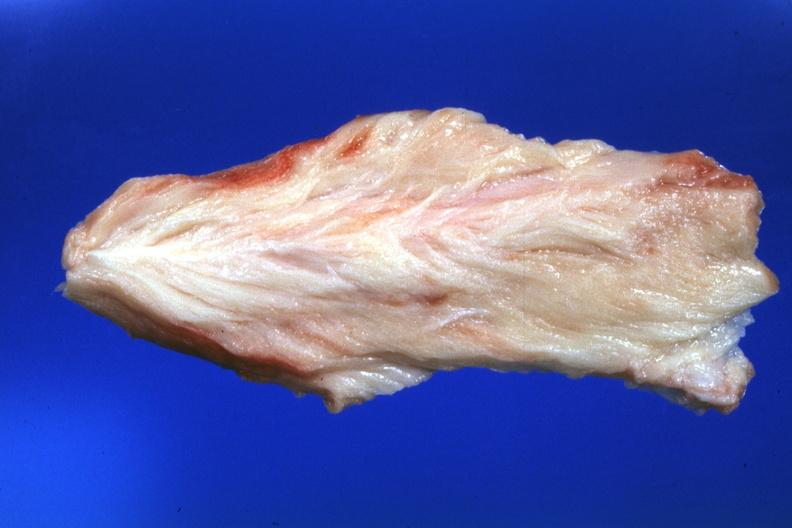s muscle atrophy present?
Answer the question using a single word or phrase. No 